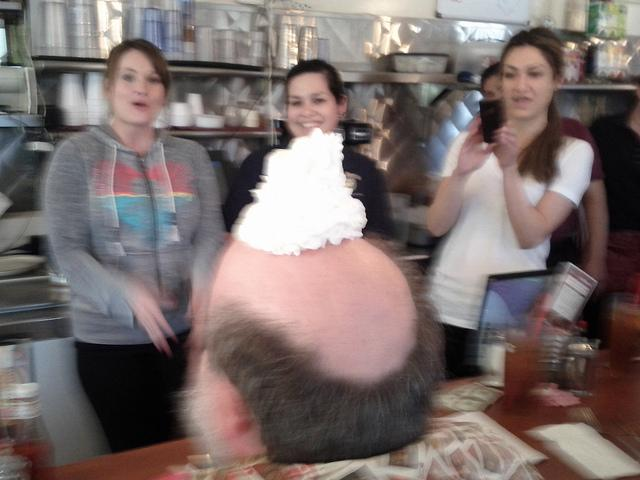What does the woman do with her phone? take picture 